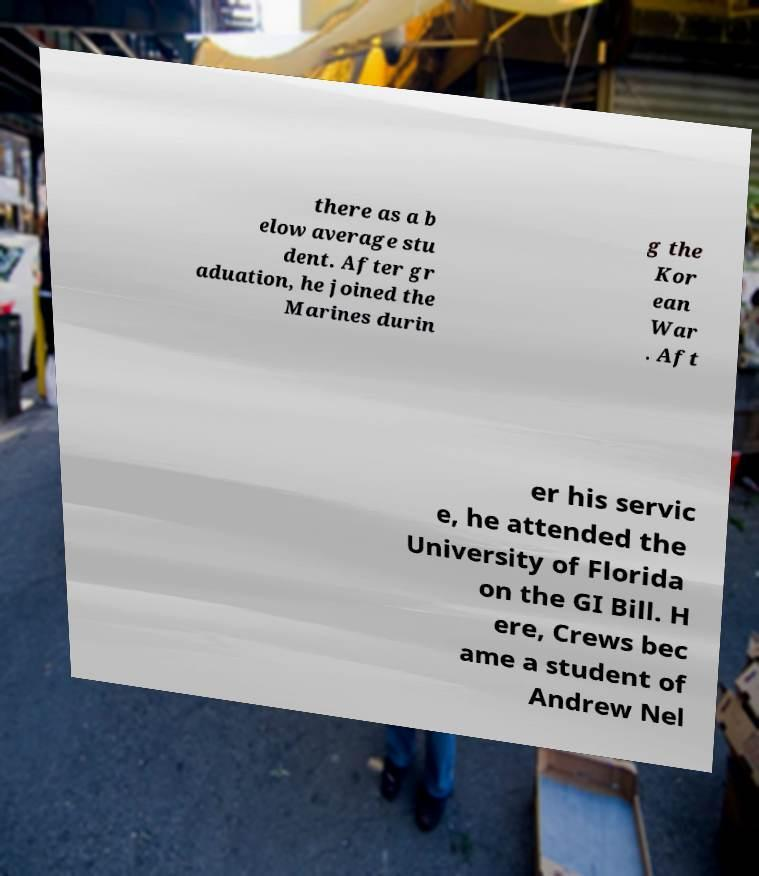For documentation purposes, I need the text within this image transcribed. Could you provide that? there as a b elow average stu dent. After gr aduation, he joined the Marines durin g the Kor ean War . Aft er his servic e, he attended the University of Florida on the GI Bill. H ere, Crews bec ame a student of Andrew Nel 